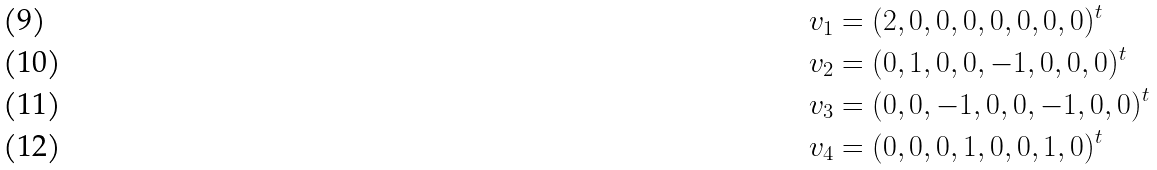Convert formula to latex. <formula><loc_0><loc_0><loc_500><loc_500>v _ { 1 } & = ( 2 , 0 , 0 , 0 , 0 , 0 , 0 , 0 ) ^ { t } \\ v _ { 2 } & = ( 0 , 1 , 0 , 0 , - 1 , 0 , 0 , 0 ) ^ { t } \\ v _ { 3 } & = ( 0 , 0 , - 1 , 0 , 0 , - 1 , 0 , 0 ) ^ { t } \\ v _ { 4 } & = ( 0 , 0 , 0 , 1 , 0 , 0 , 1 , 0 ) ^ { t }</formula> 